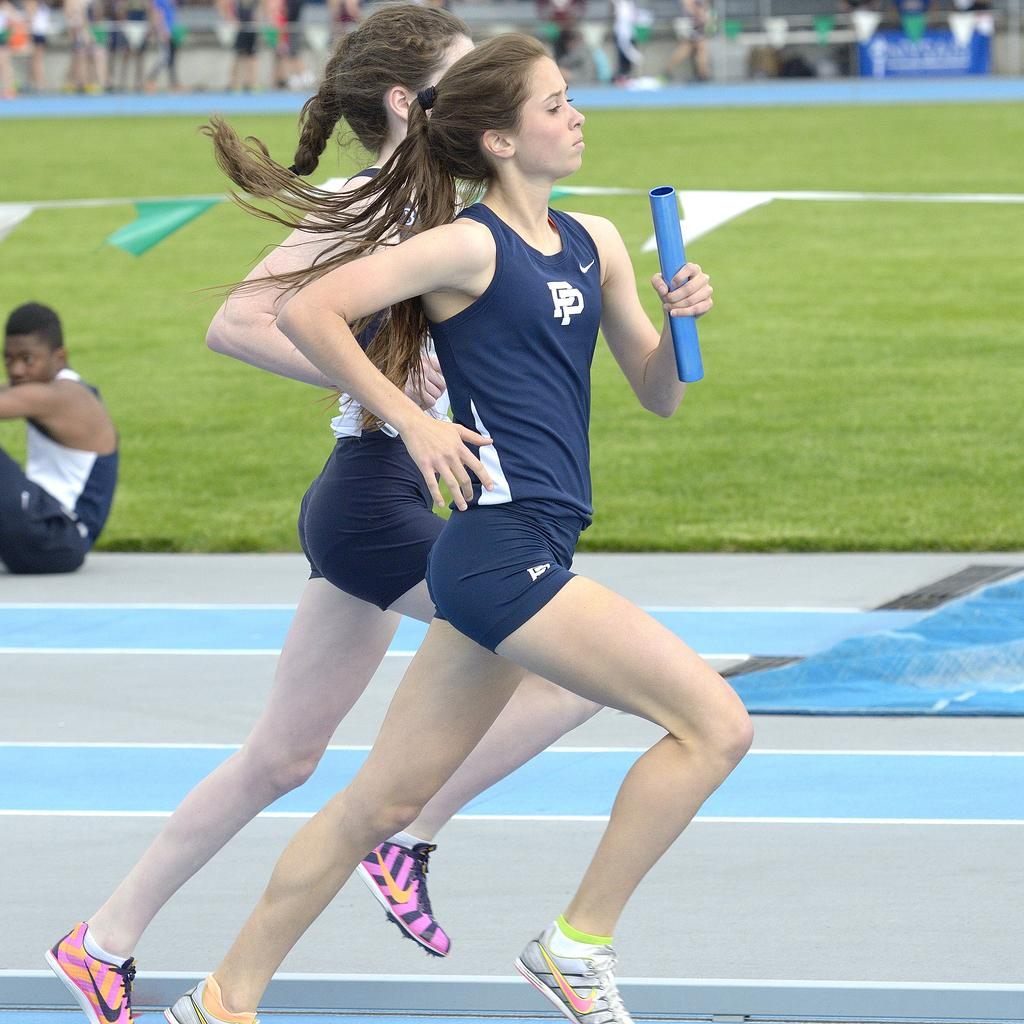What are the two women in the image doing? The two women in the image are running. What can be seen in the background of the image? There is a blue board and paper flags in the background. Are there any other people visible in the image? Yes, there are people in the background. What is the man in the image doing? The man is sitting on the floor in the image. What type of surface is visible in the image? There is grass visible in the image. What type of straw can be seen forming a circle in the image? There is no straw or circle present in the image. How many stars are visible in the image? There are no stars visible in the image. 